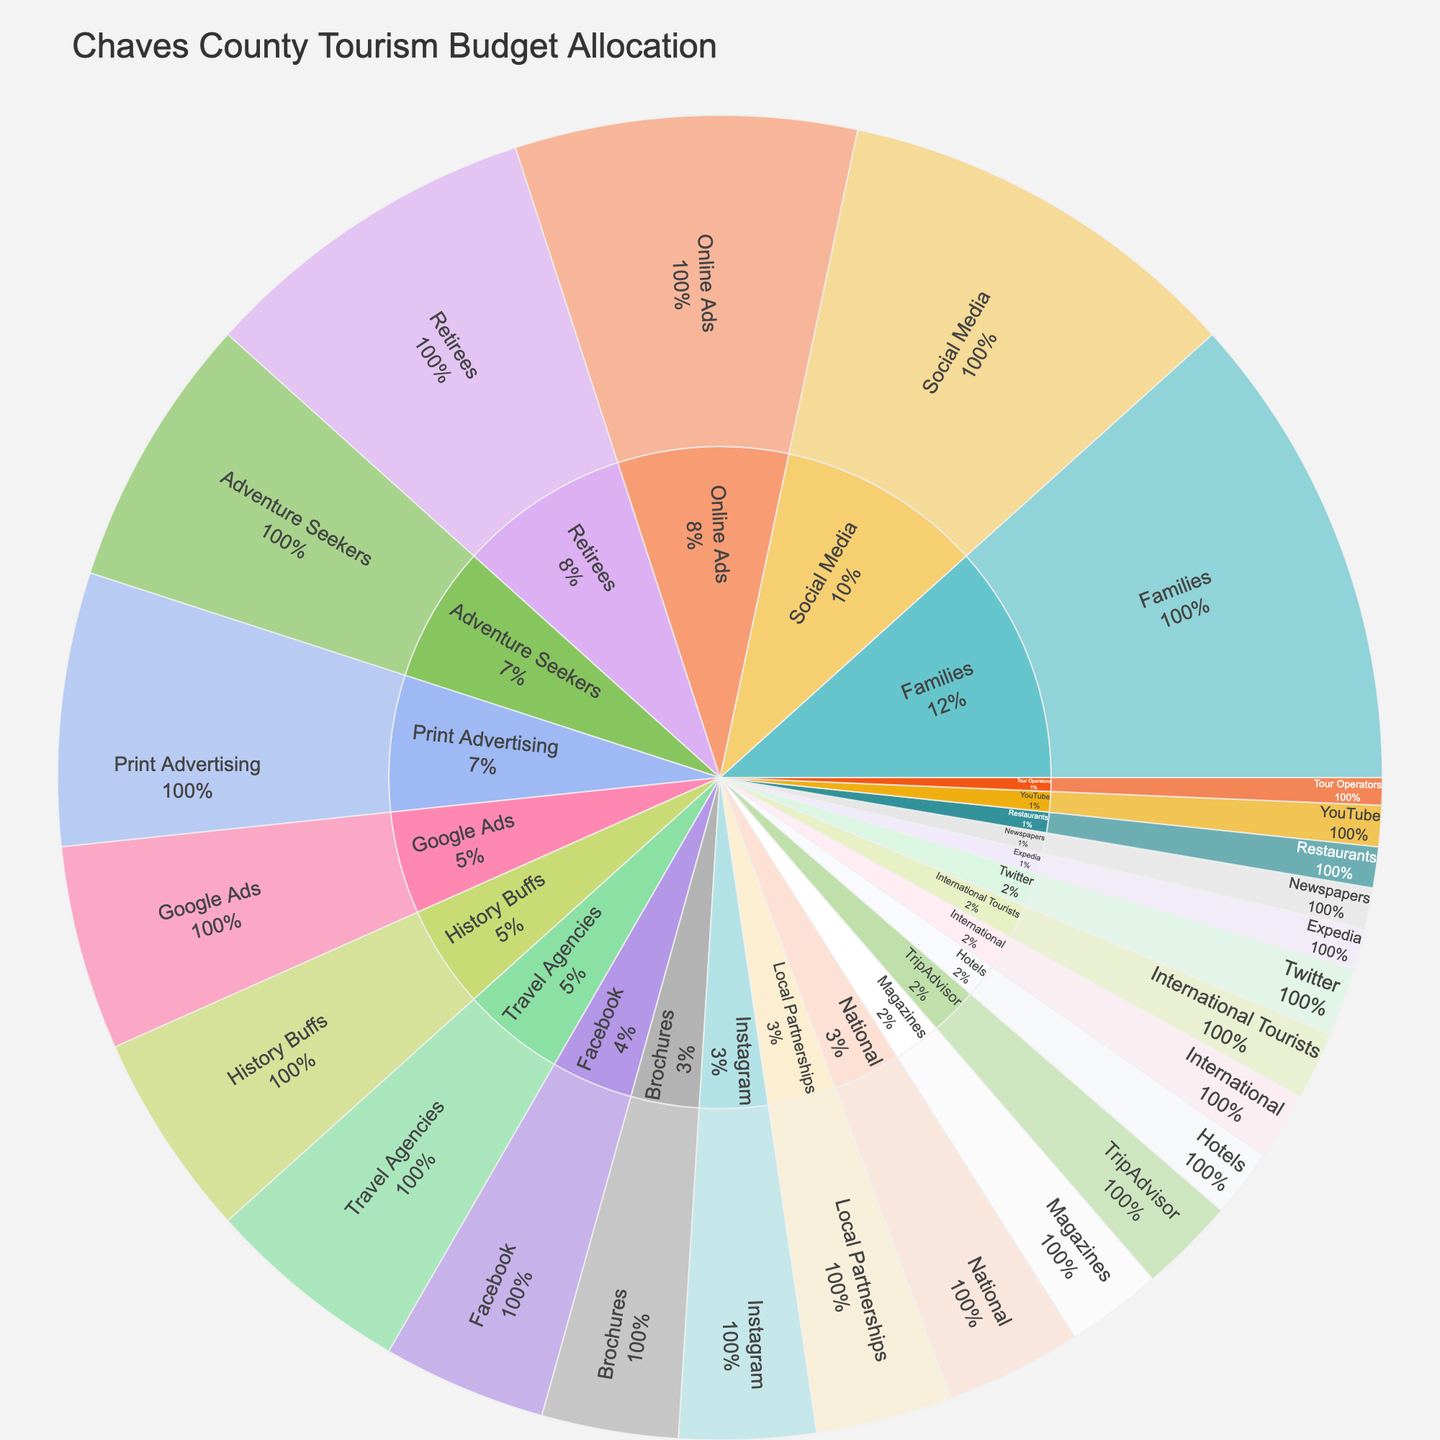What is the total budget allocated to Marketing Channels? To find the total budget for Marketing Channels, add the values for Social Media, Print Advertising, Online Ads, Travel Agencies, and Local Partnerships. That is 30 + 20 + 25 + 15 + 10 = 100.
Answer: 100 Which Marketing Channel has the highest budget allocation? Compare the budget values of Social Media, Print Advertising, Online Ads, Travel Agencies, and Local Partnerships. Social Media has the highest value with 30.
Answer: Social Media How much budget is allocated to Facebook? Look at the segment under Social Media in the sunburst plot where Facebook is listed. Facebook has a value of 12.
Answer: 12 What percentage of the Marketing Channels budget is allocated to Online Ads? The budget for Online Ads is 25, and the total budget for Marketing Channels is 100. The percentage is (25/100) * 100% = 25%.
Answer: 25% Which target demographic receives the least budget? Compare the budget values of the target demographics segments: Families, Retirees, Adventure Seekers, History Buffs, and International Tourists. International Tourists has the smallest budget with 5.
Answer: International Tourists What is the combined budget for Print Advertising and Local Partnerships? Add the values for Print Advertising and Local Partnerships. That is 20 + 10 = 30.
Answer: 30 Which social media platform has the smallest budget allocation? Compare the sub-segments under Social Media: Facebook, Instagram, Twitter, and YouTube. YouTube has the smallest budget with 3.
Answer: YouTube What is the difference in budget allocation between Families and Retirees? Subtract the value of Retirees from that of Families: 35 - 25 = 10.
Answer: 10 How much total budget is allocated to online platforms (Social Media + Online Ads)? Add the values of Social Media and Online Ads. That is 30 + 25 = 55.
Answer: 55 What is the percentage of the total budget allocated to travel agencies? The budget for Travel Agencies is 15, and the total tourism budget is calculated by summing all values, which is 200. The percentage is (15/200) * 100% = 7.5%.
Answer: 7.5% 